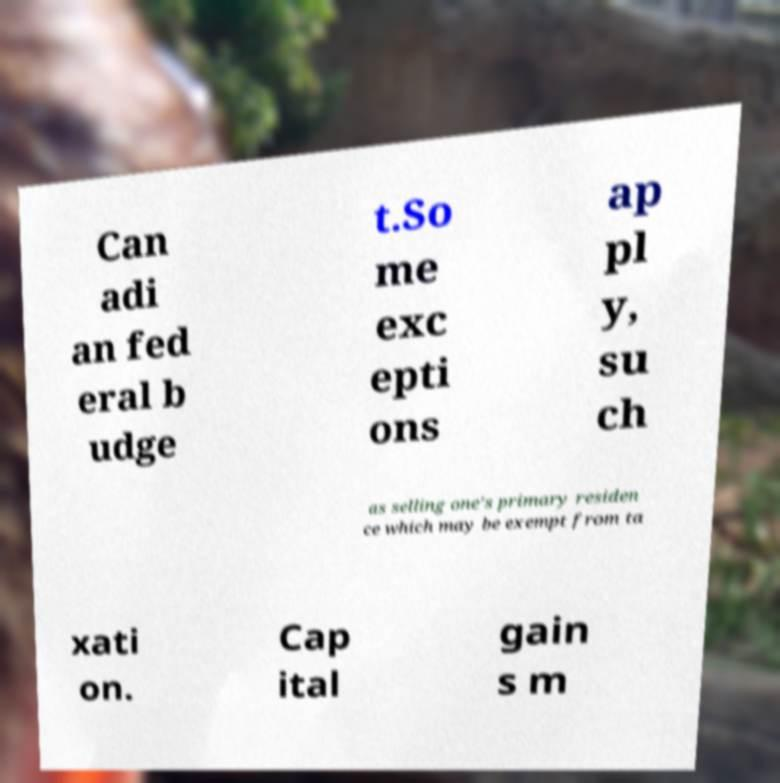There's text embedded in this image that I need extracted. Can you transcribe it verbatim? Can adi an fed eral b udge t.So me exc epti ons ap pl y, su ch as selling one's primary residen ce which may be exempt from ta xati on. Cap ital gain s m 